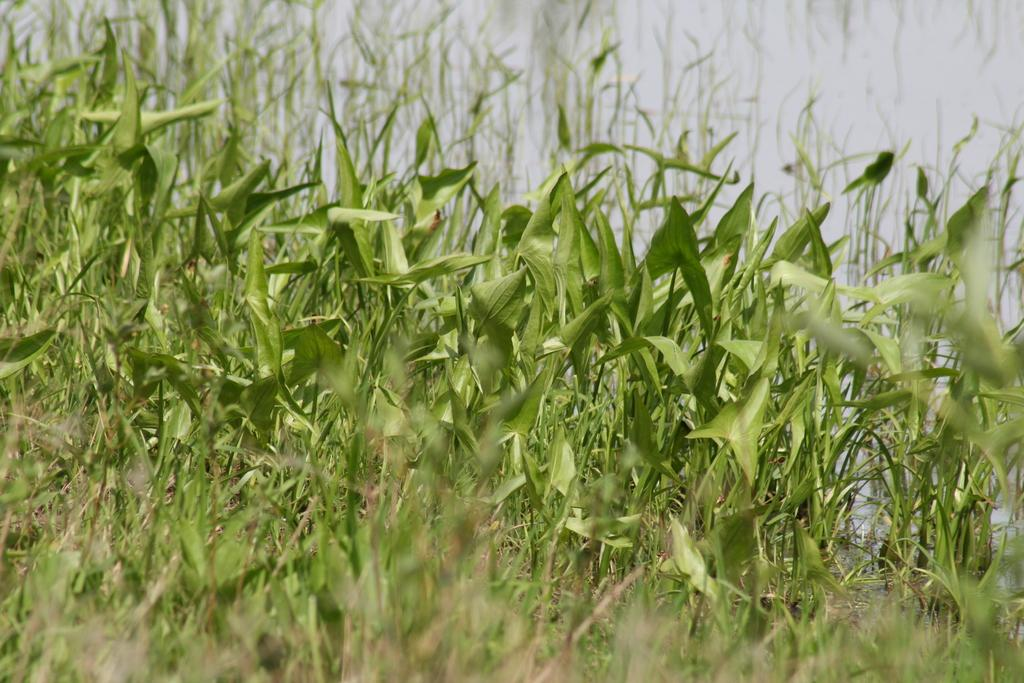What type of vegetation is in the middle of the image? There are bushes in the middle of the image. What is visible at the top of the image? The sky is visible at the top of the image. Where is the cellar located in the image? There is no cellar present in the image. What type of spot is visible on the bushes in the image? There is no spot visible on the bushes in the image. 